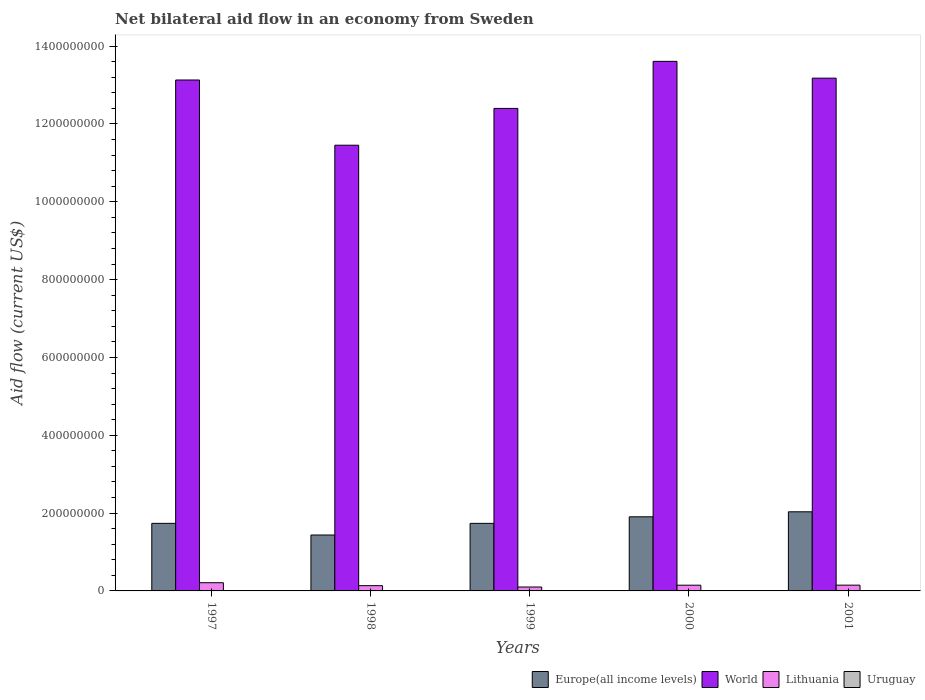How many different coloured bars are there?
Give a very brief answer. 4. How many groups of bars are there?
Your answer should be compact. 5. Are the number of bars per tick equal to the number of legend labels?
Make the answer very short. Yes. In how many cases, is the number of bars for a given year not equal to the number of legend labels?
Keep it short and to the point. 0. Across all years, what is the maximum net bilateral aid flow in Europe(all income levels)?
Your answer should be very brief. 2.03e+08. Across all years, what is the minimum net bilateral aid flow in World?
Provide a succinct answer. 1.15e+09. In which year was the net bilateral aid flow in Europe(all income levels) maximum?
Offer a very short reply. 2001. What is the total net bilateral aid flow in Europe(all income levels) in the graph?
Offer a very short reply. 8.85e+08. What is the difference between the net bilateral aid flow in World in 1997 and that in 1999?
Offer a very short reply. 7.30e+07. What is the difference between the net bilateral aid flow in Europe(all income levels) in 2000 and the net bilateral aid flow in Lithuania in 2001?
Keep it short and to the point. 1.76e+08. What is the average net bilateral aid flow in World per year?
Offer a terse response. 1.28e+09. In the year 2000, what is the difference between the net bilateral aid flow in Uruguay and net bilateral aid flow in Lithuania?
Provide a short and direct response. -1.46e+07. In how many years, is the net bilateral aid flow in Lithuania greater than 800000000 US$?
Ensure brevity in your answer.  0. What is the ratio of the net bilateral aid flow in World in 1999 to that in 2001?
Make the answer very short. 0.94. What is the difference between the highest and the second highest net bilateral aid flow in Uruguay?
Keep it short and to the point. 4.90e+05. What is the difference between the highest and the lowest net bilateral aid flow in Europe(all income levels)?
Your answer should be very brief. 5.97e+07. In how many years, is the net bilateral aid flow in Lithuania greater than the average net bilateral aid flow in Lithuania taken over all years?
Your answer should be compact. 1. Is it the case that in every year, the sum of the net bilateral aid flow in Lithuania and net bilateral aid flow in Europe(all income levels) is greater than the sum of net bilateral aid flow in Uruguay and net bilateral aid flow in World?
Your response must be concise. Yes. What does the 4th bar from the left in 1997 represents?
Provide a short and direct response. Uruguay. What does the 1st bar from the right in 2000 represents?
Make the answer very short. Uruguay. Is it the case that in every year, the sum of the net bilateral aid flow in Lithuania and net bilateral aid flow in Europe(all income levels) is greater than the net bilateral aid flow in World?
Provide a succinct answer. No. How many bars are there?
Your answer should be very brief. 20. How many years are there in the graph?
Provide a short and direct response. 5. Are the values on the major ticks of Y-axis written in scientific E-notation?
Your response must be concise. No. Does the graph contain any zero values?
Keep it short and to the point. No. How are the legend labels stacked?
Your response must be concise. Horizontal. What is the title of the graph?
Provide a short and direct response. Net bilateral aid flow in an economy from Sweden. What is the Aid flow (current US$) in Europe(all income levels) in 1997?
Keep it short and to the point. 1.74e+08. What is the Aid flow (current US$) in World in 1997?
Provide a succinct answer. 1.31e+09. What is the Aid flow (current US$) of Lithuania in 1997?
Your answer should be compact. 2.11e+07. What is the Aid flow (current US$) in Uruguay in 1997?
Ensure brevity in your answer.  9.20e+05. What is the Aid flow (current US$) in Europe(all income levels) in 1998?
Provide a succinct answer. 1.44e+08. What is the Aid flow (current US$) of World in 1998?
Ensure brevity in your answer.  1.15e+09. What is the Aid flow (current US$) of Lithuania in 1998?
Give a very brief answer. 1.35e+07. What is the Aid flow (current US$) in Uruguay in 1998?
Provide a succinct answer. 4.30e+05. What is the Aid flow (current US$) in Europe(all income levels) in 1999?
Keep it short and to the point. 1.74e+08. What is the Aid flow (current US$) in World in 1999?
Your answer should be very brief. 1.24e+09. What is the Aid flow (current US$) of Lithuania in 1999?
Offer a terse response. 1.00e+07. What is the Aid flow (current US$) in Uruguay in 1999?
Provide a short and direct response. 1.10e+05. What is the Aid flow (current US$) in Europe(all income levels) in 2000?
Your answer should be very brief. 1.90e+08. What is the Aid flow (current US$) in World in 2000?
Keep it short and to the point. 1.36e+09. What is the Aid flow (current US$) of Lithuania in 2000?
Offer a terse response. 1.47e+07. What is the Aid flow (current US$) in Uruguay in 2000?
Offer a terse response. 1.30e+05. What is the Aid flow (current US$) of Europe(all income levels) in 2001?
Make the answer very short. 2.03e+08. What is the Aid flow (current US$) in World in 2001?
Keep it short and to the point. 1.32e+09. What is the Aid flow (current US$) of Lithuania in 2001?
Offer a terse response. 1.48e+07. What is the Aid flow (current US$) of Uruguay in 2001?
Your answer should be very brief. 7.00e+04. Across all years, what is the maximum Aid flow (current US$) in Europe(all income levels)?
Ensure brevity in your answer.  2.03e+08. Across all years, what is the maximum Aid flow (current US$) of World?
Give a very brief answer. 1.36e+09. Across all years, what is the maximum Aid flow (current US$) in Lithuania?
Give a very brief answer. 2.11e+07. Across all years, what is the maximum Aid flow (current US$) in Uruguay?
Ensure brevity in your answer.  9.20e+05. Across all years, what is the minimum Aid flow (current US$) of Europe(all income levels)?
Provide a succinct answer. 1.44e+08. Across all years, what is the minimum Aid flow (current US$) of World?
Your answer should be compact. 1.15e+09. Across all years, what is the minimum Aid flow (current US$) in Lithuania?
Your answer should be compact. 1.00e+07. Across all years, what is the minimum Aid flow (current US$) in Uruguay?
Your response must be concise. 7.00e+04. What is the total Aid flow (current US$) in Europe(all income levels) in the graph?
Keep it short and to the point. 8.85e+08. What is the total Aid flow (current US$) of World in the graph?
Your answer should be very brief. 6.38e+09. What is the total Aid flow (current US$) in Lithuania in the graph?
Provide a succinct answer. 7.42e+07. What is the total Aid flow (current US$) of Uruguay in the graph?
Provide a short and direct response. 1.66e+06. What is the difference between the Aid flow (current US$) in Europe(all income levels) in 1997 and that in 1998?
Offer a very short reply. 3.00e+07. What is the difference between the Aid flow (current US$) in World in 1997 and that in 1998?
Your answer should be very brief. 1.68e+08. What is the difference between the Aid flow (current US$) in Lithuania in 1997 and that in 1998?
Your answer should be very brief. 7.59e+06. What is the difference between the Aid flow (current US$) of Uruguay in 1997 and that in 1998?
Provide a short and direct response. 4.90e+05. What is the difference between the Aid flow (current US$) of Europe(all income levels) in 1997 and that in 1999?
Make the answer very short. 5.00e+04. What is the difference between the Aid flow (current US$) in World in 1997 and that in 1999?
Offer a terse response. 7.30e+07. What is the difference between the Aid flow (current US$) in Lithuania in 1997 and that in 1999?
Keep it short and to the point. 1.11e+07. What is the difference between the Aid flow (current US$) in Uruguay in 1997 and that in 1999?
Give a very brief answer. 8.10e+05. What is the difference between the Aid flow (current US$) in Europe(all income levels) in 1997 and that in 2000?
Your response must be concise. -1.68e+07. What is the difference between the Aid flow (current US$) of World in 1997 and that in 2000?
Your answer should be compact. -4.79e+07. What is the difference between the Aid flow (current US$) in Lithuania in 1997 and that in 2000?
Provide a short and direct response. 6.38e+06. What is the difference between the Aid flow (current US$) of Uruguay in 1997 and that in 2000?
Make the answer very short. 7.90e+05. What is the difference between the Aid flow (current US$) of Europe(all income levels) in 1997 and that in 2001?
Make the answer very short. -2.97e+07. What is the difference between the Aid flow (current US$) in World in 1997 and that in 2001?
Give a very brief answer. -4.75e+06. What is the difference between the Aid flow (current US$) of Lithuania in 1997 and that in 2001?
Make the answer very short. 6.26e+06. What is the difference between the Aid flow (current US$) of Uruguay in 1997 and that in 2001?
Give a very brief answer. 8.50e+05. What is the difference between the Aid flow (current US$) in Europe(all income levels) in 1998 and that in 1999?
Offer a very short reply. -2.99e+07. What is the difference between the Aid flow (current US$) in World in 1998 and that in 1999?
Give a very brief answer. -9.46e+07. What is the difference between the Aid flow (current US$) of Lithuania in 1998 and that in 1999?
Offer a very short reply. 3.47e+06. What is the difference between the Aid flow (current US$) in Uruguay in 1998 and that in 1999?
Offer a very short reply. 3.20e+05. What is the difference between the Aid flow (current US$) of Europe(all income levels) in 1998 and that in 2000?
Provide a succinct answer. -4.68e+07. What is the difference between the Aid flow (current US$) of World in 1998 and that in 2000?
Ensure brevity in your answer.  -2.16e+08. What is the difference between the Aid flow (current US$) in Lithuania in 1998 and that in 2000?
Your answer should be very brief. -1.21e+06. What is the difference between the Aid flow (current US$) in Uruguay in 1998 and that in 2000?
Offer a terse response. 3.00e+05. What is the difference between the Aid flow (current US$) of Europe(all income levels) in 1998 and that in 2001?
Give a very brief answer. -5.97e+07. What is the difference between the Aid flow (current US$) in World in 1998 and that in 2001?
Provide a succinct answer. -1.72e+08. What is the difference between the Aid flow (current US$) of Lithuania in 1998 and that in 2001?
Your response must be concise. -1.33e+06. What is the difference between the Aid flow (current US$) of Uruguay in 1998 and that in 2001?
Offer a terse response. 3.60e+05. What is the difference between the Aid flow (current US$) of Europe(all income levels) in 1999 and that in 2000?
Make the answer very short. -1.69e+07. What is the difference between the Aid flow (current US$) in World in 1999 and that in 2000?
Your response must be concise. -1.21e+08. What is the difference between the Aid flow (current US$) of Lithuania in 1999 and that in 2000?
Give a very brief answer. -4.68e+06. What is the difference between the Aid flow (current US$) in Uruguay in 1999 and that in 2000?
Keep it short and to the point. -2.00e+04. What is the difference between the Aid flow (current US$) in Europe(all income levels) in 1999 and that in 2001?
Offer a very short reply. -2.98e+07. What is the difference between the Aid flow (current US$) in World in 1999 and that in 2001?
Offer a terse response. -7.78e+07. What is the difference between the Aid flow (current US$) of Lithuania in 1999 and that in 2001?
Your answer should be compact. -4.80e+06. What is the difference between the Aid flow (current US$) in Europe(all income levels) in 2000 and that in 2001?
Your response must be concise. -1.29e+07. What is the difference between the Aid flow (current US$) of World in 2000 and that in 2001?
Keep it short and to the point. 4.32e+07. What is the difference between the Aid flow (current US$) of Europe(all income levels) in 1997 and the Aid flow (current US$) of World in 1998?
Ensure brevity in your answer.  -9.72e+08. What is the difference between the Aid flow (current US$) of Europe(all income levels) in 1997 and the Aid flow (current US$) of Lithuania in 1998?
Offer a terse response. 1.60e+08. What is the difference between the Aid flow (current US$) in Europe(all income levels) in 1997 and the Aid flow (current US$) in Uruguay in 1998?
Give a very brief answer. 1.73e+08. What is the difference between the Aid flow (current US$) of World in 1997 and the Aid flow (current US$) of Lithuania in 1998?
Provide a succinct answer. 1.30e+09. What is the difference between the Aid flow (current US$) of World in 1997 and the Aid flow (current US$) of Uruguay in 1998?
Keep it short and to the point. 1.31e+09. What is the difference between the Aid flow (current US$) in Lithuania in 1997 and the Aid flow (current US$) in Uruguay in 1998?
Provide a succinct answer. 2.07e+07. What is the difference between the Aid flow (current US$) in Europe(all income levels) in 1997 and the Aid flow (current US$) in World in 1999?
Make the answer very short. -1.07e+09. What is the difference between the Aid flow (current US$) in Europe(all income levels) in 1997 and the Aid flow (current US$) in Lithuania in 1999?
Ensure brevity in your answer.  1.64e+08. What is the difference between the Aid flow (current US$) of Europe(all income levels) in 1997 and the Aid flow (current US$) of Uruguay in 1999?
Ensure brevity in your answer.  1.74e+08. What is the difference between the Aid flow (current US$) in World in 1997 and the Aid flow (current US$) in Lithuania in 1999?
Provide a succinct answer. 1.30e+09. What is the difference between the Aid flow (current US$) of World in 1997 and the Aid flow (current US$) of Uruguay in 1999?
Offer a very short reply. 1.31e+09. What is the difference between the Aid flow (current US$) of Lithuania in 1997 and the Aid flow (current US$) of Uruguay in 1999?
Ensure brevity in your answer.  2.10e+07. What is the difference between the Aid flow (current US$) of Europe(all income levels) in 1997 and the Aid flow (current US$) of World in 2000?
Offer a very short reply. -1.19e+09. What is the difference between the Aid flow (current US$) of Europe(all income levels) in 1997 and the Aid flow (current US$) of Lithuania in 2000?
Provide a succinct answer. 1.59e+08. What is the difference between the Aid flow (current US$) of Europe(all income levels) in 1997 and the Aid flow (current US$) of Uruguay in 2000?
Provide a succinct answer. 1.74e+08. What is the difference between the Aid flow (current US$) of World in 1997 and the Aid flow (current US$) of Lithuania in 2000?
Provide a short and direct response. 1.30e+09. What is the difference between the Aid flow (current US$) of World in 1997 and the Aid flow (current US$) of Uruguay in 2000?
Keep it short and to the point. 1.31e+09. What is the difference between the Aid flow (current US$) of Lithuania in 1997 and the Aid flow (current US$) of Uruguay in 2000?
Offer a terse response. 2.10e+07. What is the difference between the Aid flow (current US$) in Europe(all income levels) in 1997 and the Aid flow (current US$) in World in 2001?
Offer a terse response. -1.14e+09. What is the difference between the Aid flow (current US$) in Europe(all income levels) in 1997 and the Aid flow (current US$) in Lithuania in 2001?
Ensure brevity in your answer.  1.59e+08. What is the difference between the Aid flow (current US$) of Europe(all income levels) in 1997 and the Aid flow (current US$) of Uruguay in 2001?
Offer a terse response. 1.74e+08. What is the difference between the Aid flow (current US$) in World in 1997 and the Aid flow (current US$) in Lithuania in 2001?
Keep it short and to the point. 1.30e+09. What is the difference between the Aid flow (current US$) in World in 1997 and the Aid flow (current US$) in Uruguay in 2001?
Ensure brevity in your answer.  1.31e+09. What is the difference between the Aid flow (current US$) in Lithuania in 1997 and the Aid flow (current US$) in Uruguay in 2001?
Your answer should be compact. 2.10e+07. What is the difference between the Aid flow (current US$) in Europe(all income levels) in 1998 and the Aid flow (current US$) in World in 1999?
Give a very brief answer. -1.10e+09. What is the difference between the Aid flow (current US$) of Europe(all income levels) in 1998 and the Aid flow (current US$) of Lithuania in 1999?
Keep it short and to the point. 1.34e+08. What is the difference between the Aid flow (current US$) of Europe(all income levels) in 1998 and the Aid flow (current US$) of Uruguay in 1999?
Your answer should be very brief. 1.44e+08. What is the difference between the Aid flow (current US$) of World in 1998 and the Aid flow (current US$) of Lithuania in 1999?
Your answer should be very brief. 1.14e+09. What is the difference between the Aid flow (current US$) of World in 1998 and the Aid flow (current US$) of Uruguay in 1999?
Offer a terse response. 1.15e+09. What is the difference between the Aid flow (current US$) of Lithuania in 1998 and the Aid flow (current US$) of Uruguay in 1999?
Offer a terse response. 1.34e+07. What is the difference between the Aid flow (current US$) in Europe(all income levels) in 1998 and the Aid flow (current US$) in World in 2000?
Your answer should be compact. -1.22e+09. What is the difference between the Aid flow (current US$) of Europe(all income levels) in 1998 and the Aid flow (current US$) of Lithuania in 2000?
Give a very brief answer. 1.29e+08. What is the difference between the Aid flow (current US$) of Europe(all income levels) in 1998 and the Aid flow (current US$) of Uruguay in 2000?
Provide a succinct answer. 1.44e+08. What is the difference between the Aid flow (current US$) in World in 1998 and the Aid flow (current US$) in Lithuania in 2000?
Provide a succinct answer. 1.13e+09. What is the difference between the Aid flow (current US$) of World in 1998 and the Aid flow (current US$) of Uruguay in 2000?
Give a very brief answer. 1.15e+09. What is the difference between the Aid flow (current US$) in Lithuania in 1998 and the Aid flow (current US$) in Uruguay in 2000?
Make the answer very short. 1.34e+07. What is the difference between the Aid flow (current US$) of Europe(all income levels) in 1998 and the Aid flow (current US$) of World in 2001?
Offer a terse response. -1.17e+09. What is the difference between the Aid flow (current US$) in Europe(all income levels) in 1998 and the Aid flow (current US$) in Lithuania in 2001?
Provide a succinct answer. 1.29e+08. What is the difference between the Aid flow (current US$) of Europe(all income levels) in 1998 and the Aid flow (current US$) of Uruguay in 2001?
Give a very brief answer. 1.44e+08. What is the difference between the Aid flow (current US$) of World in 1998 and the Aid flow (current US$) of Lithuania in 2001?
Your answer should be very brief. 1.13e+09. What is the difference between the Aid flow (current US$) in World in 1998 and the Aid flow (current US$) in Uruguay in 2001?
Offer a very short reply. 1.15e+09. What is the difference between the Aid flow (current US$) of Lithuania in 1998 and the Aid flow (current US$) of Uruguay in 2001?
Your answer should be very brief. 1.34e+07. What is the difference between the Aid flow (current US$) of Europe(all income levels) in 1999 and the Aid flow (current US$) of World in 2000?
Ensure brevity in your answer.  -1.19e+09. What is the difference between the Aid flow (current US$) in Europe(all income levels) in 1999 and the Aid flow (current US$) in Lithuania in 2000?
Your answer should be very brief. 1.59e+08. What is the difference between the Aid flow (current US$) in Europe(all income levels) in 1999 and the Aid flow (current US$) in Uruguay in 2000?
Offer a very short reply. 1.73e+08. What is the difference between the Aid flow (current US$) in World in 1999 and the Aid flow (current US$) in Lithuania in 2000?
Make the answer very short. 1.23e+09. What is the difference between the Aid flow (current US$) in World in 1999 and the Aid flow (current US$) in Uruguay in 2000?
Your response must be concise. 1.24e+09. What is the difference between the Aid flow (current US$) in Lithuania in 1999 and the Aid flow (current US$) in Uruguay in 2000?
Provide a short and direct response. 9.91e+06. What is the difference between the Aid flow (current US$) of Europe(all income levels) in 1999 and the Aid flow (current US$) of World in 2001?
Ensure brevity in your answer.  -1.14e+09. What is the difference between the Aid flow (current US$) in Europe(all income levels) in 1999 and the Aid flow (current US$) in Lithuania in 2001?
Provide a short and direct response. 1.59e+08. What is the difference between the Aid flow (current US$) in Europe(all income levels) in 1999 and the Aid flow (current US$) in Uruguay in 2001?
Make the answer very short. 1.74e+08. What is the difference between the Aid flow (current US$) in World in 1999 and the Aid flow (current US$) in Lithuania in 2001?
Offer a very short reply. 1.23e+09. What is the difference between the Aid flow (current US$) in World in 1999 and the Aid flow (current US$) in Uruguay in 2001?
Ensure brevity in your answer.  1.24e+09. What is the difference between the Aid flow (current US$) in Lithuania in 1999 and the Aid flow (current US$) in Uruguay in 2001?
Give a very brief answer. 9.97e+06. What is the difference between the Aid flow (current US$) in Europe(all income levels) in 2000 and the Aid flow (current US$) in World in 2001?
Your answer should be very brief. -1.13e+09. What is the difference between the Aid flow (current US$) of Europe(all income levels) in 2000 and the Aid flow (current US$) of Lithuania in 2001?
Ensure brevity in your answer.  1.76e+08. What is the difference between the Aid flow (current US$) of Europe(all income levels) in 2000 and the Aid flow (current US$) of Uruguay in 2001?
Your answer should be compact. 1.90e+08. What is the difference between the Aid flow (current US$) in World in 2000 and the Aid flow (current US$) in Lithuania in 2001?
Your response must be concise. 1.35e+09. What is the difference between the Aid flow (current US$) of World in 2000 and the Aid flow (current US$) of Uruguay in 2001?
Your response must be concise. 1.36e+09. What is the difference between the Aid flow (current US$) in Lithuania in 2000 and the Aid flow (current US$) in Uruguay in 2001?
Offer a terse response. 1.46e+07. What is the average Aid flow (current US$) in Europe(all income levels) per year?
Offer a very short reply. 1.77e+08. What is the average Aid flow (current US$) in World per year?
Offer a terse response. 1.28e+09. What is the average Aid flow (current US$) in Lithuania per year?
Provide a succinct answer. 1.48e+07. What is the average Aid flow (current US$) of Uruguay per year?
Ensure brevity in your answer.  3.32e+05. In the year 1997, what is the difference between the Aid flow (current US$) of Europe(all income levels) and Aid flow (current US$) of World?
Your answer should be very brief. -1.14e+09. In the year 1997, what is the difference between the Aid flow (current US$) in Europe(all income levels) and Aid flow (current US$) in Lithuania?
Your answer should be compact. 1.53e+08. In the year 1997, what is the difference between the Aid flow (current US$) of Europe(all income levels) and Aid flow (current US$) of Uruguay?
Keep it short and to the point. 1.73e+08. In the year 1997, what is the difference between the Aid flow (current US$) of World and Aid flow (current US$) of Lithuania?
Make the answer very short. 1.29e+09. In the year 1997, what is the difference between the Aid flow (current US$) in World and Aid flow (current US$) in Uruguay?
Offer a very short reply. 1.31e+09. In the year 1997, what is the difference between the Aid flow (current US$) of Lithuania and Aid flow (current US$) of Uruguay?
Offer a terse response. 2.02e+07. In the year 1998, what is the difference between the Aid flow (current US$) in Europe(all income levels) and Aid flow (current US$) in World?
Your answer should be compact. -1.00e+09. In the year 1998, what is the difference between the Aid flow (current US$) in Europe(all income levels) and Aid flow (current US$) in Lithuania?
Offer a very short reply. 1.30e+08. In the year 1998, what is the difference between the Aid flow (current US$) of Europe(all income levels) and Aid flow (current US$) of Uruguay?
Offer a very short reply. 1.43e+08. In the year 1998, what is the difference between the Aid flow (current US$) of World and Aid flow (current US$) of Lithuania?
Ensure brevity in your answer.  1.13e+09. In the year 1998, what is the difference between the Aid flow (current US$) in World and Aid flow (current US$) in Uruguay?
Keep it short and to the point. 1.15e+09. In the year 1998, what is the difference between the Aid flow (current US$) of Lithuania and Aid flow (current US$) of Uruguay?
Provide a succinct answer. 1.31e+07. In the year 1999, what is the difference between the Aid flow (current US$) of Europe(all income levels) and Aid flow (current US$) of World?
Make the answer very short. -1.07e+09. In the year 1999, what is the difference between the Aid flow (current US$) of Europe(all income levels) and Aid flow (current US$) of Lithuania?
Ensure brevity in your answer.  1.64e+08. In the year 1999, what is the difference between the Aid flow (current US$) of Europe(all income levels) and Aid flow (current US$) of Uruguay?
Give a very brief answer. 1.73e+08. In the year 1999, what is the difference between the Aid flow (current US$) of World and Aid flow (current US$) of Lithuania?
Your answer should be very brief. 1.23e+09. In the year 1999, what is the difference between the Aid flow (current US$) in World and Aid flow (current US$) in Uruguay?
Give a very brief answer. 1.24e+09. In the year 1999, what is the difference between the Aid flow (current US$) in Lithuania and Aid flow (current US$) in Uruguay?
Offer a very short reply. 9.93e+06. In the year 2000, what is the difference between the Aid flow (current US$) of Europe(all income levels) and Aid flow (current US$) of World?
Offer a very short reply. -1.17e+09. In the year 2000, what is the difference between the Aid flow (current US$) of Europe(all income levels) and Aid flow (current US$) of Lithuania?
Offer a very short reply. 1.76e+08. In the year 2000, what is the difference between the Aid flow (current US$) in Europe(all income levels) and Aid flow (current US$) in Uruguay?
Your response must be concise. 1.90e+08. In the year 2000, what is the difference between the Aid flow (current US$) of World and Aid flow (current US$) of Lithuania?
Offer a terse response. 1.35e+09. In the year 2000, what is the difference between the Aid flow (current US$) of World and Aid flow (current US$) of Uruguay?
Provide a succinct answer. 1.36e+09. In the year 2000, what is the difference between the Aid flow (current US$) in Lithuania and Aid flow (current US$) in Uruguay?
Keep it short and to the point. 1.46e+07. In the year 2001, what is the difference between the Aid flow (current US$) of Europe(all income levels) and Aid flow (current US$) of World?
Provide a succinct answer. -1.11e+09. In the year 2001, what is the difference between the Aid flow (current US$) of Europe(all income levels) and Aid flow (current US$) of Lithuania?
Your answer should be very brief. 1.88e+08. In the year 2001, what is the difference between the Aid flow (current US$) of Europe(all income levels) and Aid flow (current US$) of Uruguay?
Keep it short and to the point. 2.03e+08. In the year 2001, what is the difference between the Aid flow (current US$) in World and Aid flow (current US$) in Lithuania?
Your response must be concise. 1.30e+09. In the year 2001, what is the difference between the Aid flow (current US$) of World and Aid flow (current US$) of Uruguay?
Make the answer very short. 1.32e+09. In the year 2001, what is the difference between the Aid flow (current US$) of Lithuania and Aid flow (current US$) of Uruguay?
Make the answer very short. 1.48e+07. What is the ratio of the Aid flow (current US$) of Europe(all income levels) in 1997 to that in 1998?
Keep it short and to the point. 1.21. What is the ratio of the Aid flow (current US$) of World in 1997 to that in 1998?
Offer a terse response. 1.15. What is the ratio of the Aid flow (current US$) of Lithuania in 1997 to that in 1998?
Your answer should be compact. 1.56. What is the ratio of the Aid flow (current US$) of Uruguay in 1997 to that in 1998?
Provide a succinct answer. 2.14. What is the ratio of the Aid flow (current US$) of Europe(all income levels) in 1997 to that in 1999?
Ensure brevity in your answer.  1. What is the ratio of the Aid flow (current US$) in World in 1997 to that in 1999?
Keep it short and to the point. 1.06. What is the ratio of the Aid flow (current US$) in Lithuania in 1997 to that in 1999?
Offer a very short reply. 2.1. What is the ratio of the Aid flow (current US$) in Uruguay in 1997 to that in 1999?
Provide a succinct answer. 8.36. What is the ratio of the Aid flow (current US$) in Europe(all income levels) in 1997 to that in 2000?
Ensure brevity in your answer.  0.91. What is the ratio of the Aid flow (current US$) in World in 1997 to that in 2000?
Ensure brevity in your answer.  0.96. What is the ratio of the Aid flow (current US$) of Lithuania in 1997 to that in 2000?
Offer a very short reply. 1.43. What is the ratio of the Aid flow (current US$) of Uruguay in 1997 to that in 2000?
Provide a succinct answer. 7.08. What is the ratio of the Aid flow (current US$) in Europe(all income levels) in 1997 to that in 2001?
Your response must be concise. 0.85. What is the ratio of the Aid flow (current US$) in Lithuania in 1997 to that in 2001?
Provide a short and direct response. 1.42. What is the ratio of the Aid flow (current US$) in Uruguay in 1997 to that in 2001?
Make the answer very short. 13.14. What is the ratio of the Aid flow (current US$) in Europe(all income levels) in 1998 to that in 1999?
Ensure brevity in your answer.  0.83. What is the ratio of the Aid flow (current US$) in World in 1998 to that in 1999?
Your response must be concise. 0.92. What is the ratio of the Aid flow (current US$) in Lithuania in 1998 to that in 1999?
Offer a very short reply. 1.35. What is the ratio of the Aid flow (current US$) in Uruguay in 1998 to that in 1999?
Your answer should be very brief. 3.91. What is the ratio of the Aid flow (current US$) in Europe(all income levels) in 1998 to that in 2000?
Your response must be concise. 0.75. What is the ratio of the Aid flow (current US$) of World in 1998 to that in 2000?
Provide a short and direct response. 0.84. What is the ratio of the Aid flow (current US$) of Lithuania in 1998 to that in 2000?
Your response must be concise. 0.92. What is the ratio of the Aid flow (current US$) in Uruguay in 1998 to that in 2000?
Ensure brevity in your answer.  3.31. What is the ratio of the Aid flow (current US$) of Europe(all income levels) in 1998 to that in 2001?
Make the answer very short. 0.71. What is the ratio of the Aid flow (current US$) of World in 1998 to that in 2001?
Ensure brevity in your answer.  0.87. What is the ratio of the Aid flow (current US$) of Lithuania in 1998 to that in 2001?
Give a very brief answer. 0.91. What is the ratio of the Aid flow (current US$) in Uruguay in 1998 to that in 2001?
Ensure brevity in your answer.  6.14. What is the ratio of the Aid flow (current US$) in Europe(all income levels) in 1999 to that in 2000?
Your answer should be very brief. 0.91. What is the ratio of the Aid flow (current US$) in World in 1999 to that in 2000?
Provide a short and direct response. 0.91. What is the ratio of the Aid flow (current US$) in Lithuania in 1999 to that in 2000?
Provide a succinct answer. 0.68. What is the ratio of the Aid flow (current US$) of Uruguay in 1999 to that in 2000?
Ensure brevity in your answer.  0.85. What is the ratio of the Aid flow (current US$) in Europe(all income levels) in 1999 to that in 2001?
Your answer should be very brief. 0.85. What is the ratio of the Aid flow (current US$) in World in 1999 to that in 2001?
Your answer should be very brief. 0.94. What is the ratio of the Aid flow (current US$) of Lithuania in 1999 to that in 2001?
Give a very brief answer. 0.68. What is the ratio of the Aid flow (current US$) of Uruguay in 1999 to that in 2001?
Provide a succinct answer. 1.57. What is the ratio of the Aid flow (current US$) in Europe(all income levels) in 2000 to that in 2001?
Provide a succinct answer. 0.94. What is the ratio of the Aid flow (current US$) of World in 2000 to that in 2001?
Give a very brief answer. 1.03. What is the ratio of the Aid flow (current US$) of Uruguay in 2000 to that in 2001?
Your answer should be compact. 1.86. What is the difference between the highest and the second highest Aid flow (current US$) of Europe(all income levels)?
Keep it short and to the point. 1.29e+07. What is the difference between the highest and the second highest Aid flow (current US$) of World?
Keep it short and to the point. 4.32e+07. What is the difference between the highest and the second highest Aid flow (current US$) in Lithuania?
Ensure brevity in your answer.  6.26e+06. What is the difference between the highest and the second highest Aid flow (current US$) of Uruguay?
Make the answer very short. 4.90e+05. What is the difference between the highest and the lowest Aid flow (current US$) of Europe(all income levels)?
Keep it short and to the point. 5.97e+07. What is the difference between the highest and the lowest Aid flow (current US$) in World?
Your answer should be compact. 2.16e+08. What is the difference between the highest and the lowest Aid flow (current US$) in Lithuania?
Provide a short and direct response. 1.11e+07. What is the difference between the highest and the lowest Aid flow (current US$) in Uruguay?
Offer a very short reply. 8.50e+05. 